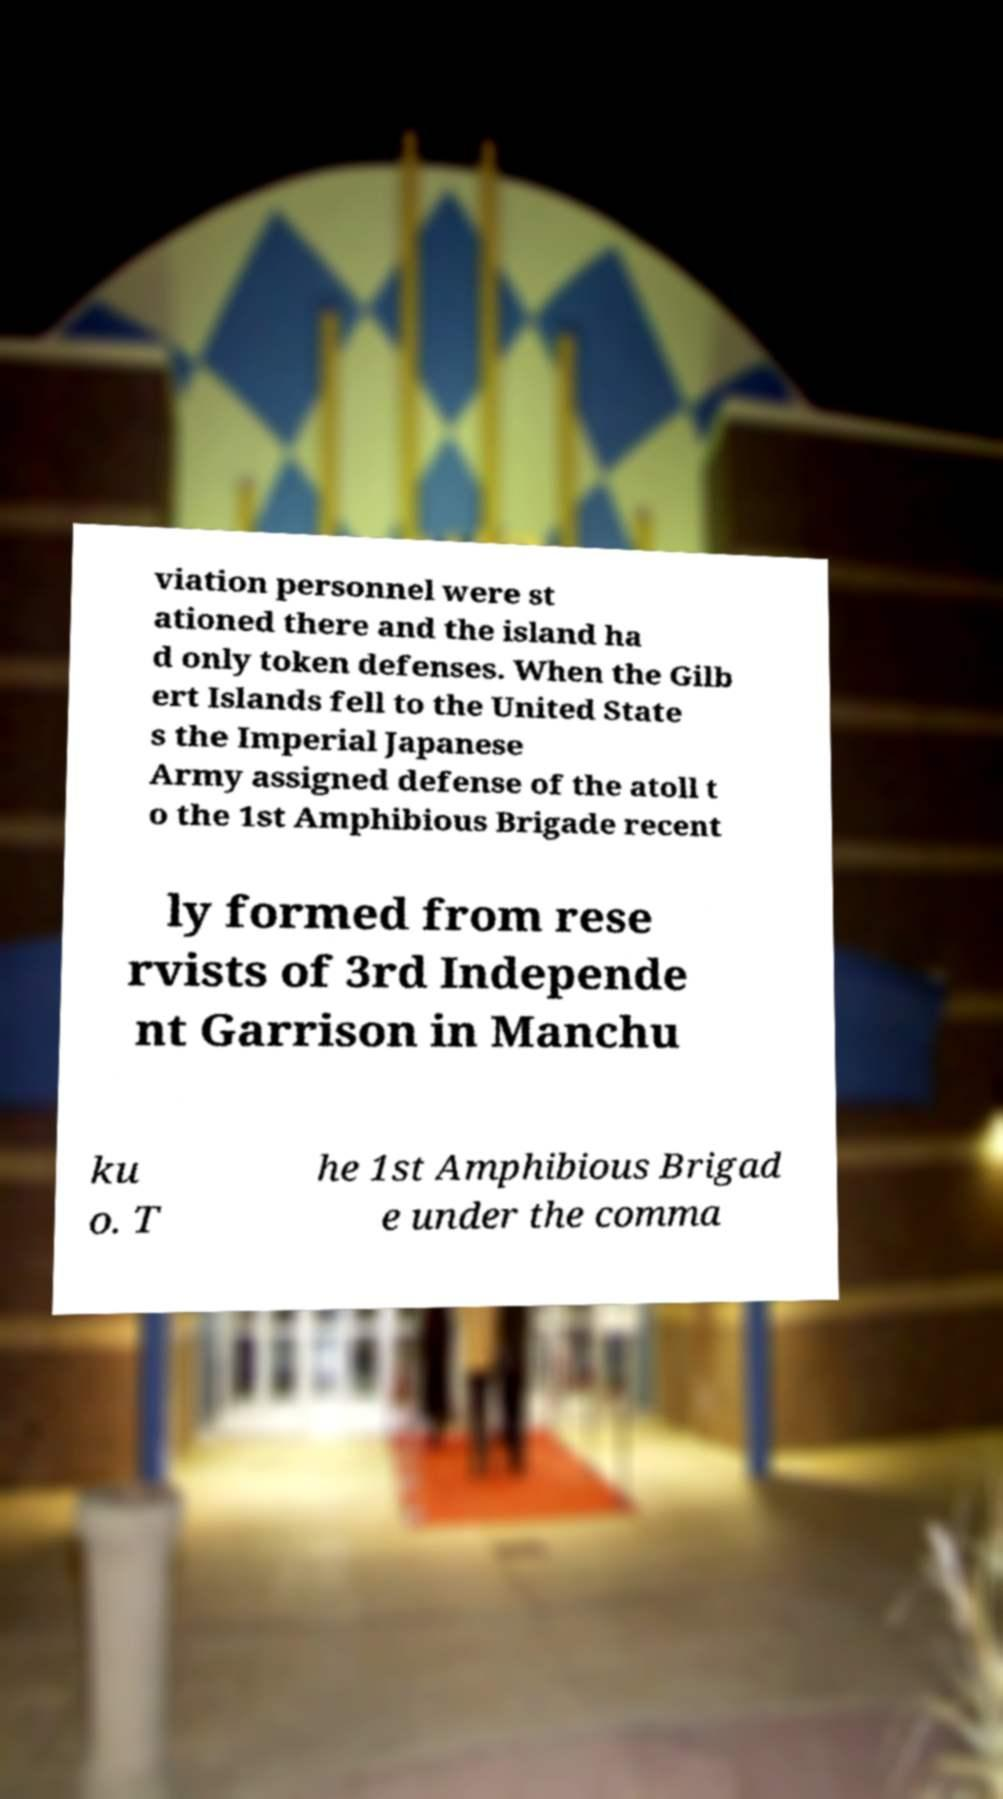Can you read and provide the text displayed in the image?This photo seems to have some interesting text. Can you extract and type it out for me? viation personnel were st ationed there and the island ha d only token defenses. When the Gilb ert Islands fell to the United State s the Imperial Japanese Army assigned defense of the atoll t o the 1st Amphibious Brigade recent ly formed from rese rvists of 3rd Independe nt Garrison in Manchu ku o. T he 1st Amphibious Brigad e under the comma 